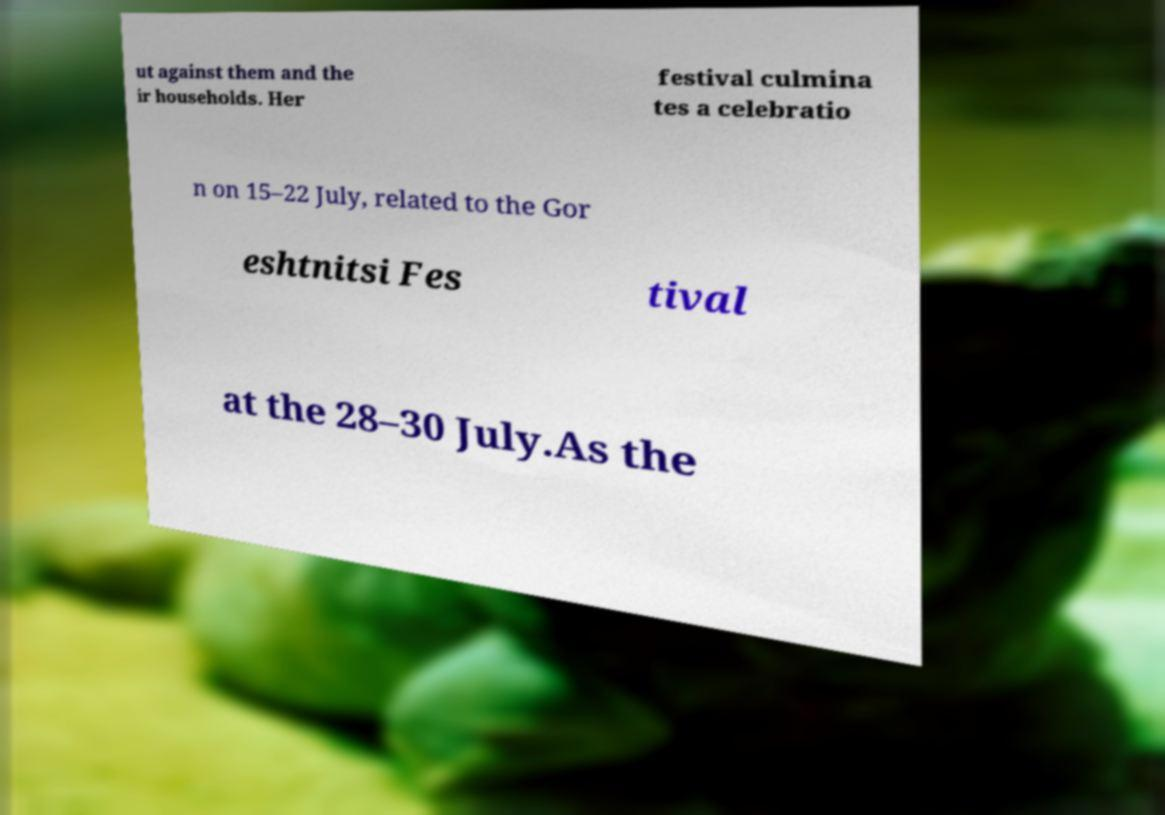Can you read and provide the text displayed in the image?This photo seems to have some interesting text. Can you extract and type it out for me? ut against them and the ir households. Her festival culmina tes a celebratio n on 15–22 July, related to the Gor eshtnitsi Fes tival at the 28–30 July.As the 